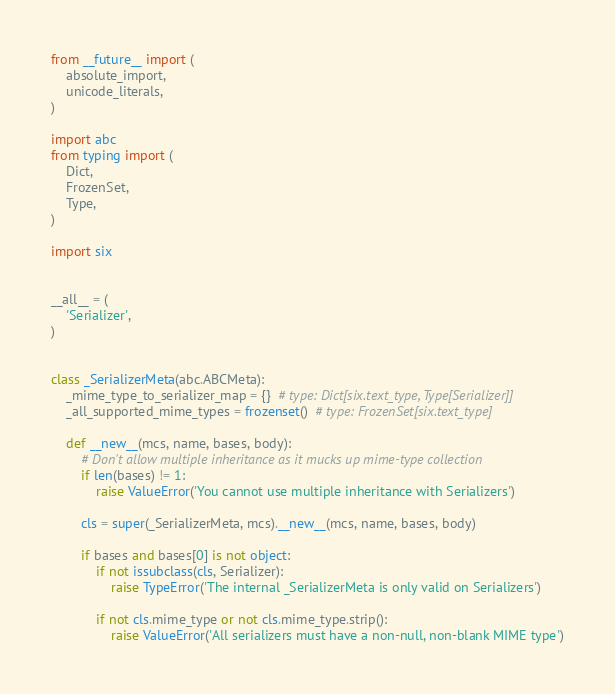Convert code to text. <code><loc_0><loc_0><loc_500><loc_500><_Python_>from __future__ import (
    absolute_import,
    unicode_literals,
)

import abc
from typing import (
    Dict,
    FrozenSet,
    Type,
)

import six


__all__ = (
    'Serializer',
)


class _SerializerMeta(abc.ABCMeta):
    _mime_type_to_serializer_map = {}  # type: Dict[six.text_type, Type[Serializer]]
    _all_supported_mime_types = frozenset()  # type: FrozenSet[six.text_type]

    def __new__(mcs, name, bases, body):
        # Don't allow multiple inheritance as it mucks up mime-type collection
        if len(bases) != 1:
            raise ValueError('You cannot use multiple inheritance with Serializers')

        cls = super(_SerializerMeta, mcs).__new__(mcs, name, bases, body)

        if bases and bases[0] is not object:
            if not issubclass(cls, Serializer):
                raise TypeError('The internal _SerializerMeta is only valid on Serializers')

            if not cls.mime_type or not cls.mime_type.strip():
                raise ValueError('All serializers must have a non-null, non-blank MIME type')
</code> 